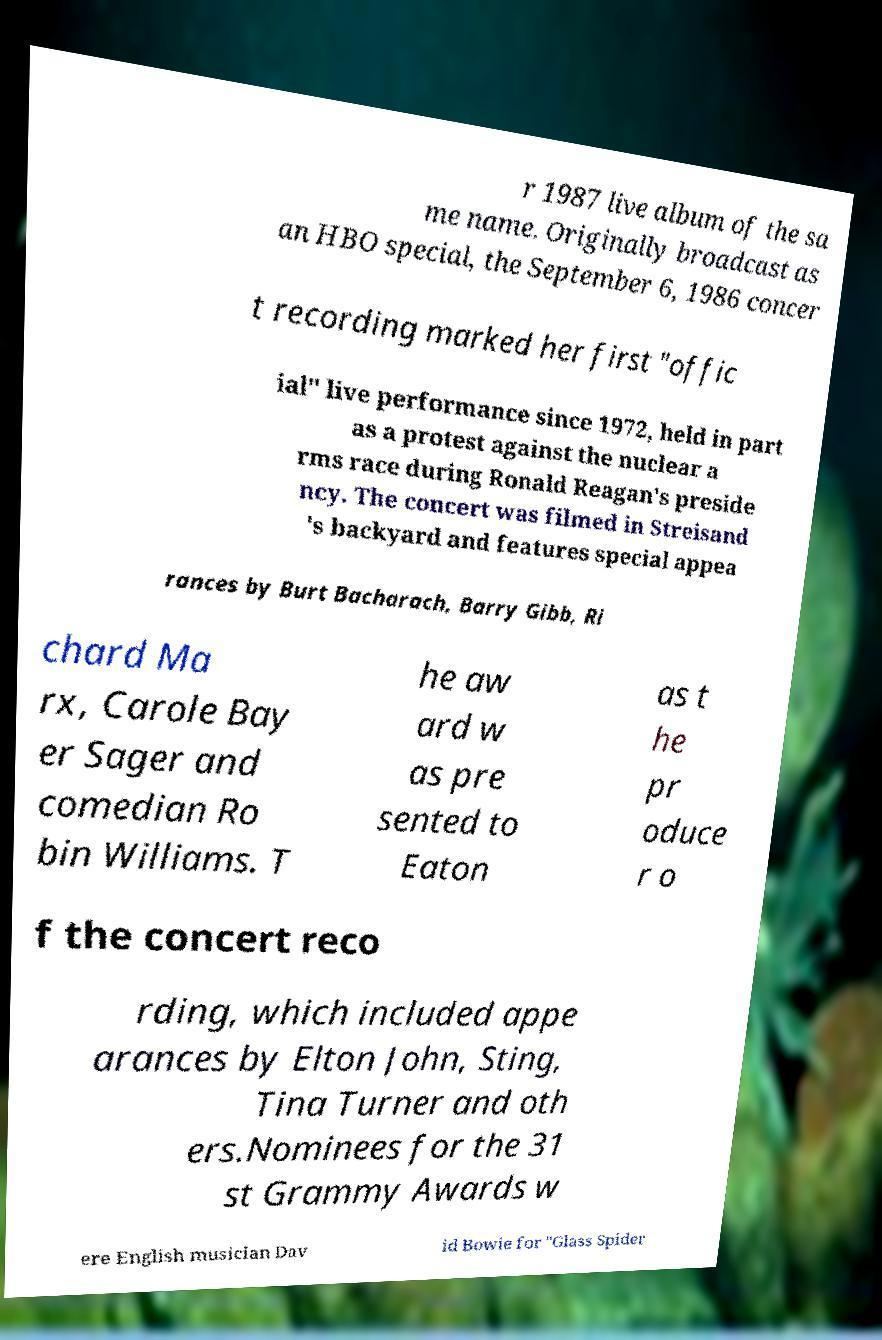Please read and relay the text visible in this image. What does it say? r 1987 live album of the sa me name. Originally broadcast as an HBO special, the September 6, 1986 concer t recording marked her first "offic ial" live performance since 1972, held in part as a protest against the nuclear a rms race during Ronald Reagan's preside ncy. The concert was filmed in Streisand 's backyard and features special appea rances by Burt Bacharach, Barry Gibb, Ri chard Ma rx, Carole Bay er Sager and comedian Ro bin Williams. T he aw ard w as pre sented to Eaton as t he pr oduce r o f the concert reco rding, which included appe arances by Elton John, Sting, Tina Turner and oth ers.Nominees for the 31 st Grammy Awards w ere English musician Dav id Bowie for "Glass Spider 